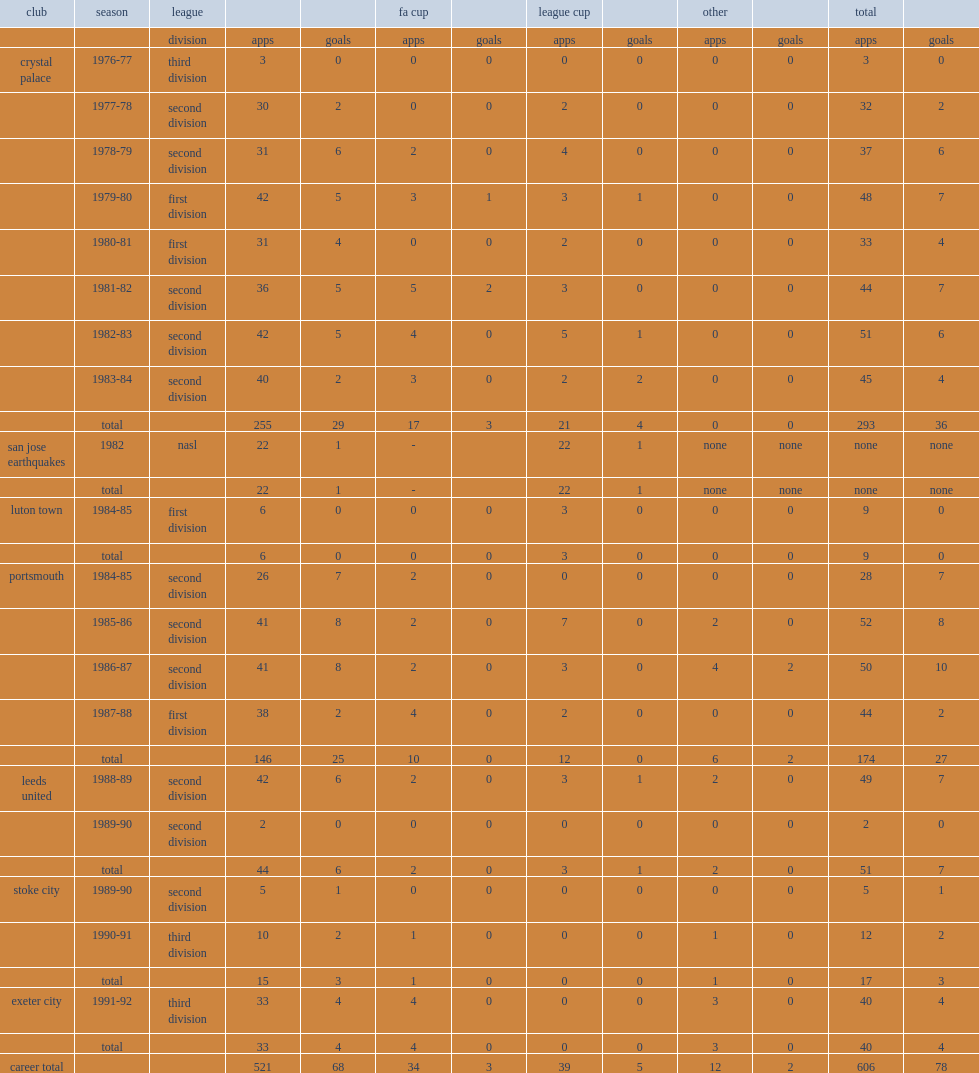Vince hilaire joined luton town in 1984 but made only six appearances before being to portsmouth in 1984, how many appearances did he make? 146.0. Vince hilaire joined luton town in 1984 but made only six appearances before being to portsmouth in 1984, how many goals did he score? 25.0. 